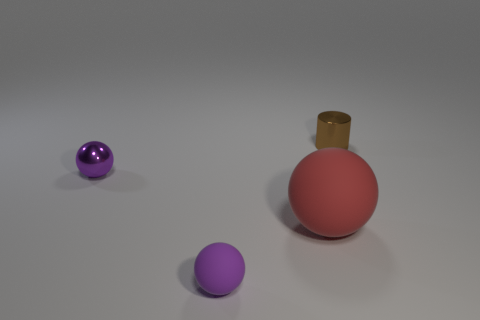What number of things are either large spheres behind the tiny purple rubber ball or small purple rubber things that are in front of the tiny purple metallic sphere?
Provide a succinct answer. 2. There is a brown cylinder that is the same size as the purple metal sphere; what is it made of?
Provide a short and direct response. Metal. What color is the large thing?
Your answer should be very brief. Red. There is a object that is both behind the big red thing and to the left of the big red thing; what material is it?
Ensure brevity in your answer.  Metal. Is there a large red ball in front of the purple thing that is right of the tiny metallic thing that is in front of the tiny shiny cylinder?
Your response must be concise. No. The other thing that is the same color as the tiny matte object is what size?
Provide a short and direct response. Small. Are there any purple matte things on the left side of the purple matte ball?
Provide a succinct answer. No. What number of other objects are there of the same shape as the big matte thing?
Provide a succinct answer. 2. What color is the metal object that is the same size as the brown cylinder?
Offer a terse response. Purple. Is the number of large rubber balls to the right of the big red sphere less than the number of tiny purple metal things that are behind the purple shiny sphere?
Offer a terse response. No. 